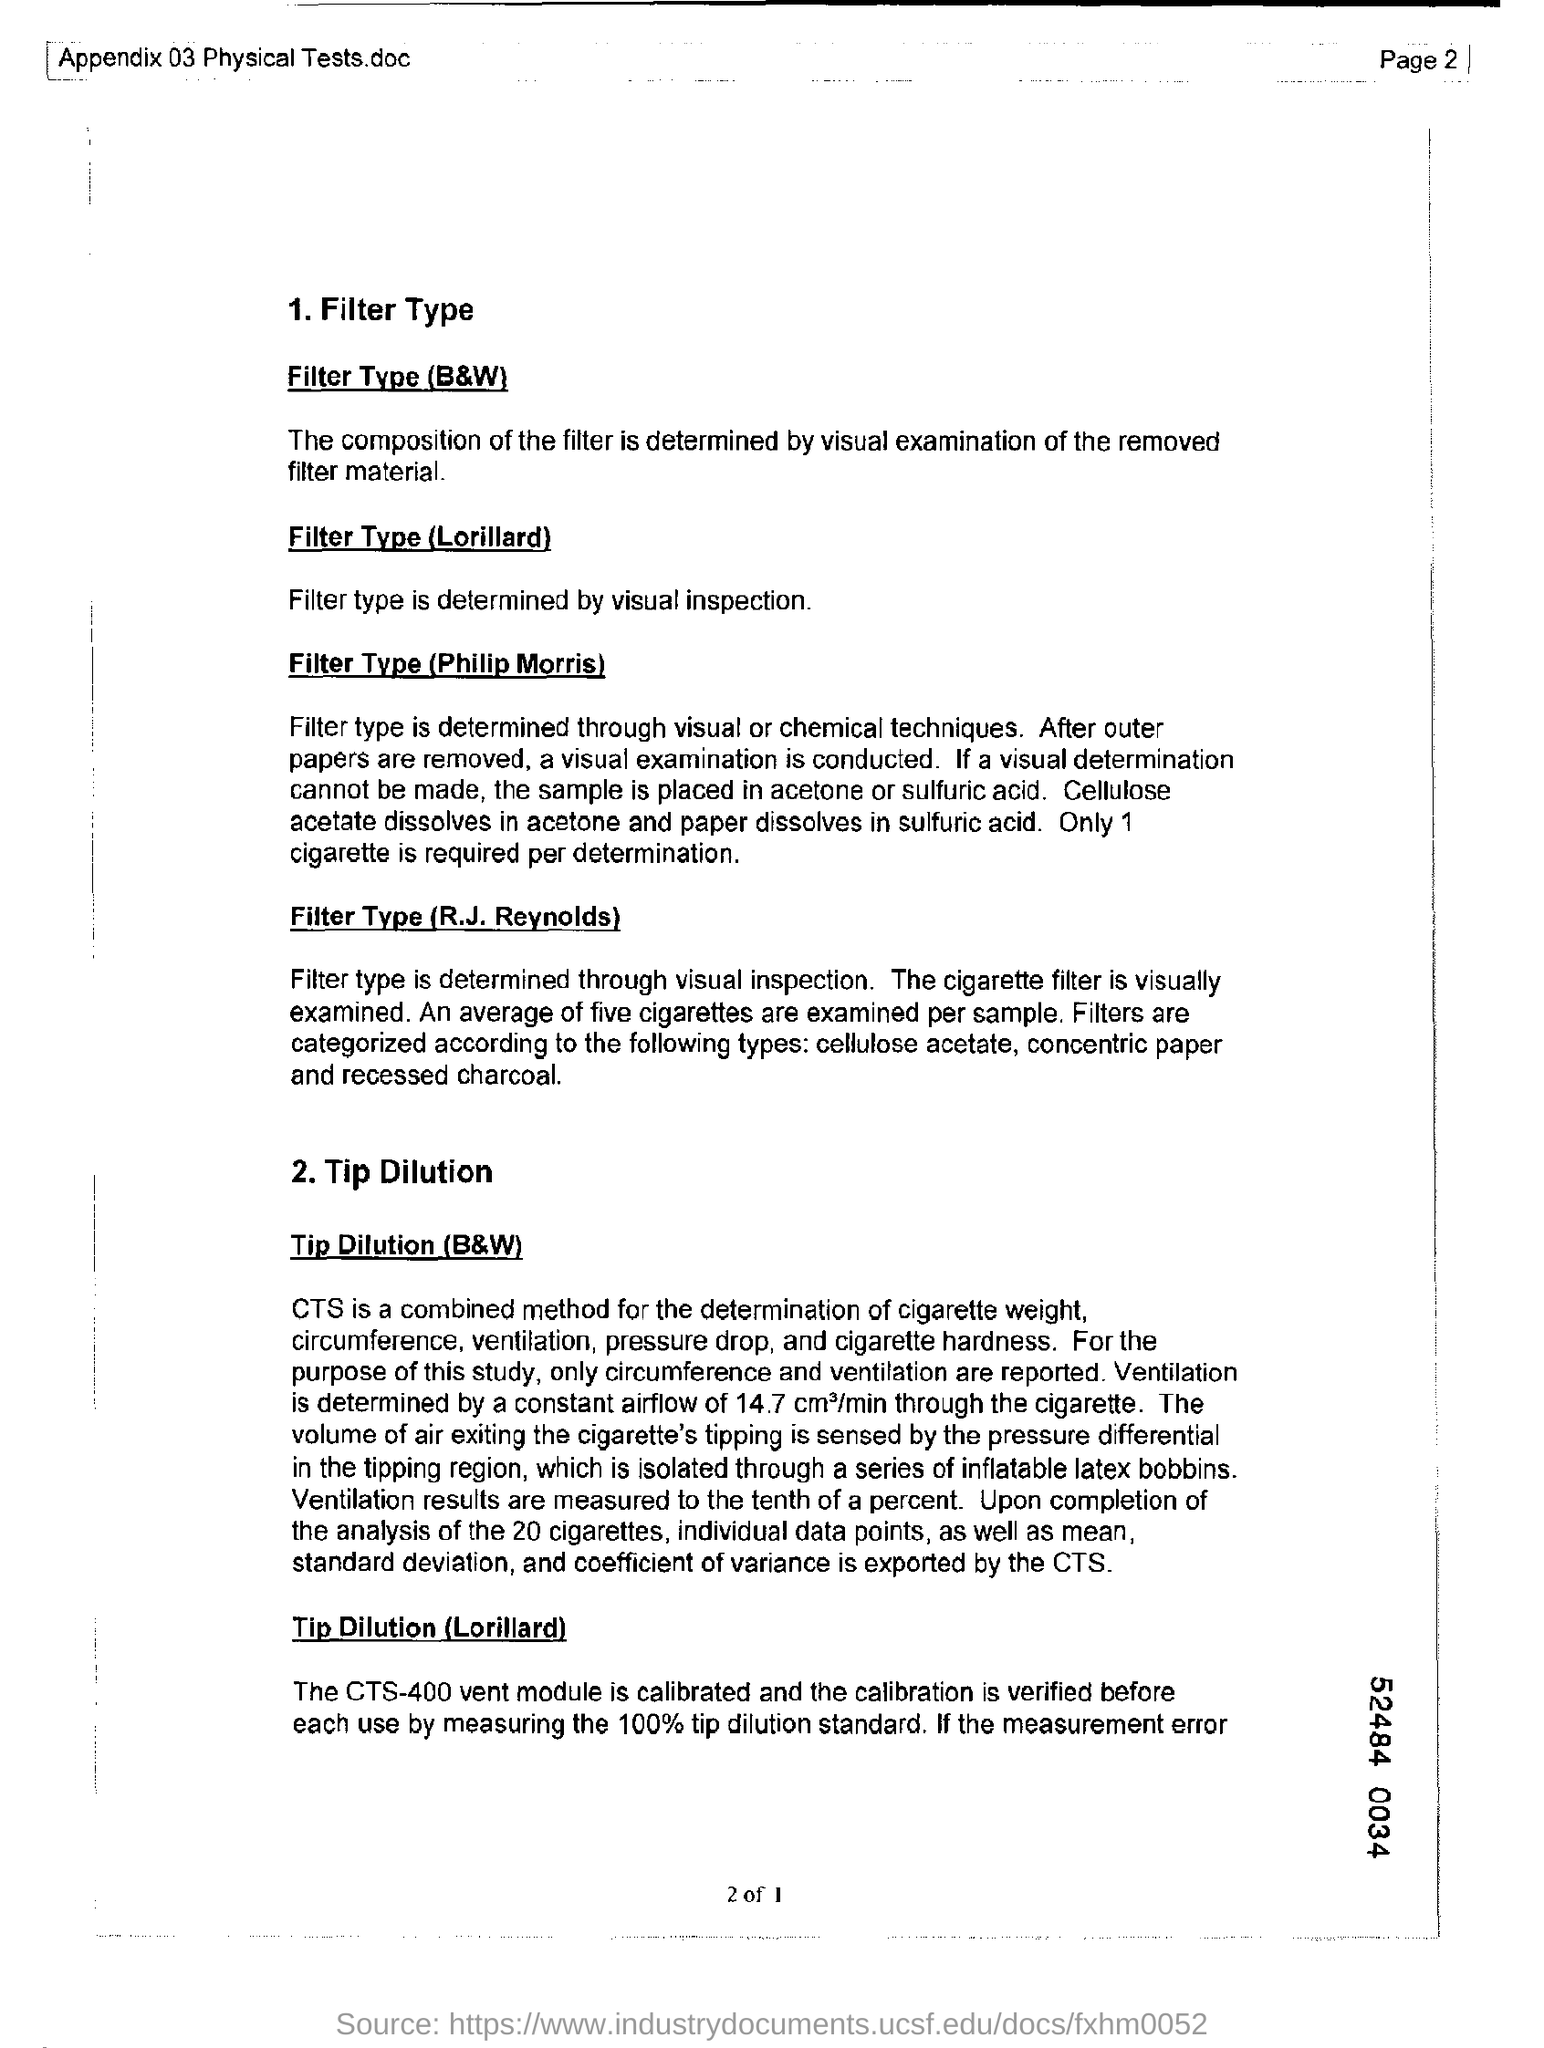What determines the Filter Type (Lorillard)?
Keep it short and to the point. Visual inspection. What determines the Filter Type (Philip Morris)?
Provide a short and direct response. Visual or chemical techniques. What is the combined method for the determination of cigarette weight?
Make the answer very short. CTS. 